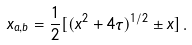Convert formula to latex. <formula><loc_0><loc_0><loc_500><loc_500>x _ { a , b } = \frac { 1 } { 2 } [ ( x ^ { 2 } + 4 \tau ) ^ { 1 / 2 } \pm x ] \, .</formula> 